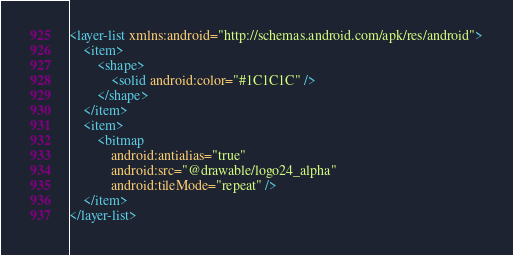Convert code to text. <code><loc_0><loc_0><loc_500><loc_500><_XML_><layer-list xmlns:android="http://schemas.android.com/apk/res/android">
    <item>
        <shape>
            <solid android:color="#1C1C1C" />
        </shape>
    </item>
    <item>
        <bitmap
            android:antialias="true"
            android:src="@drawable/logo24_alpha"
            android:tileMode="repeat" />
    </item>
</layer-list></code> 